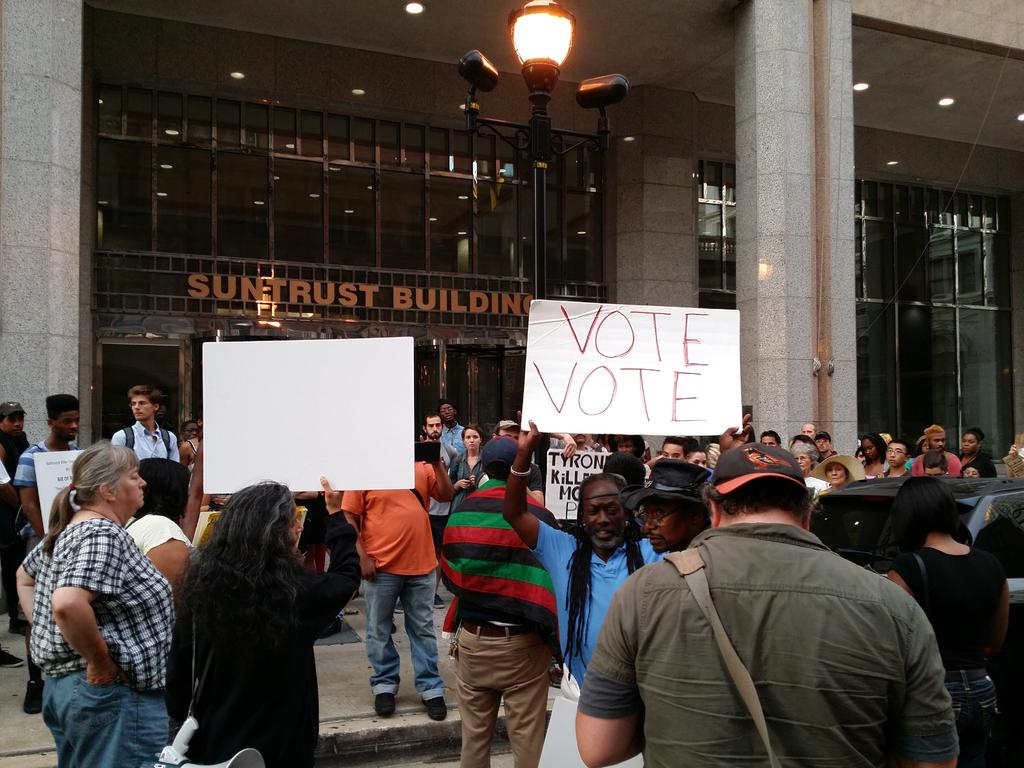Who or what is present in the image? There are people in the image. What type of structure can be seen in the image? There is a building in the image. Can you describe any other elements in the image? There is a light visible in the image. What type of copper distribution system can be seen in the image? There is no copper distribution system present in the image. How many children are visible in the image? There is no mention of children in the provided facts, so we cannot determine the number of children in the image. 